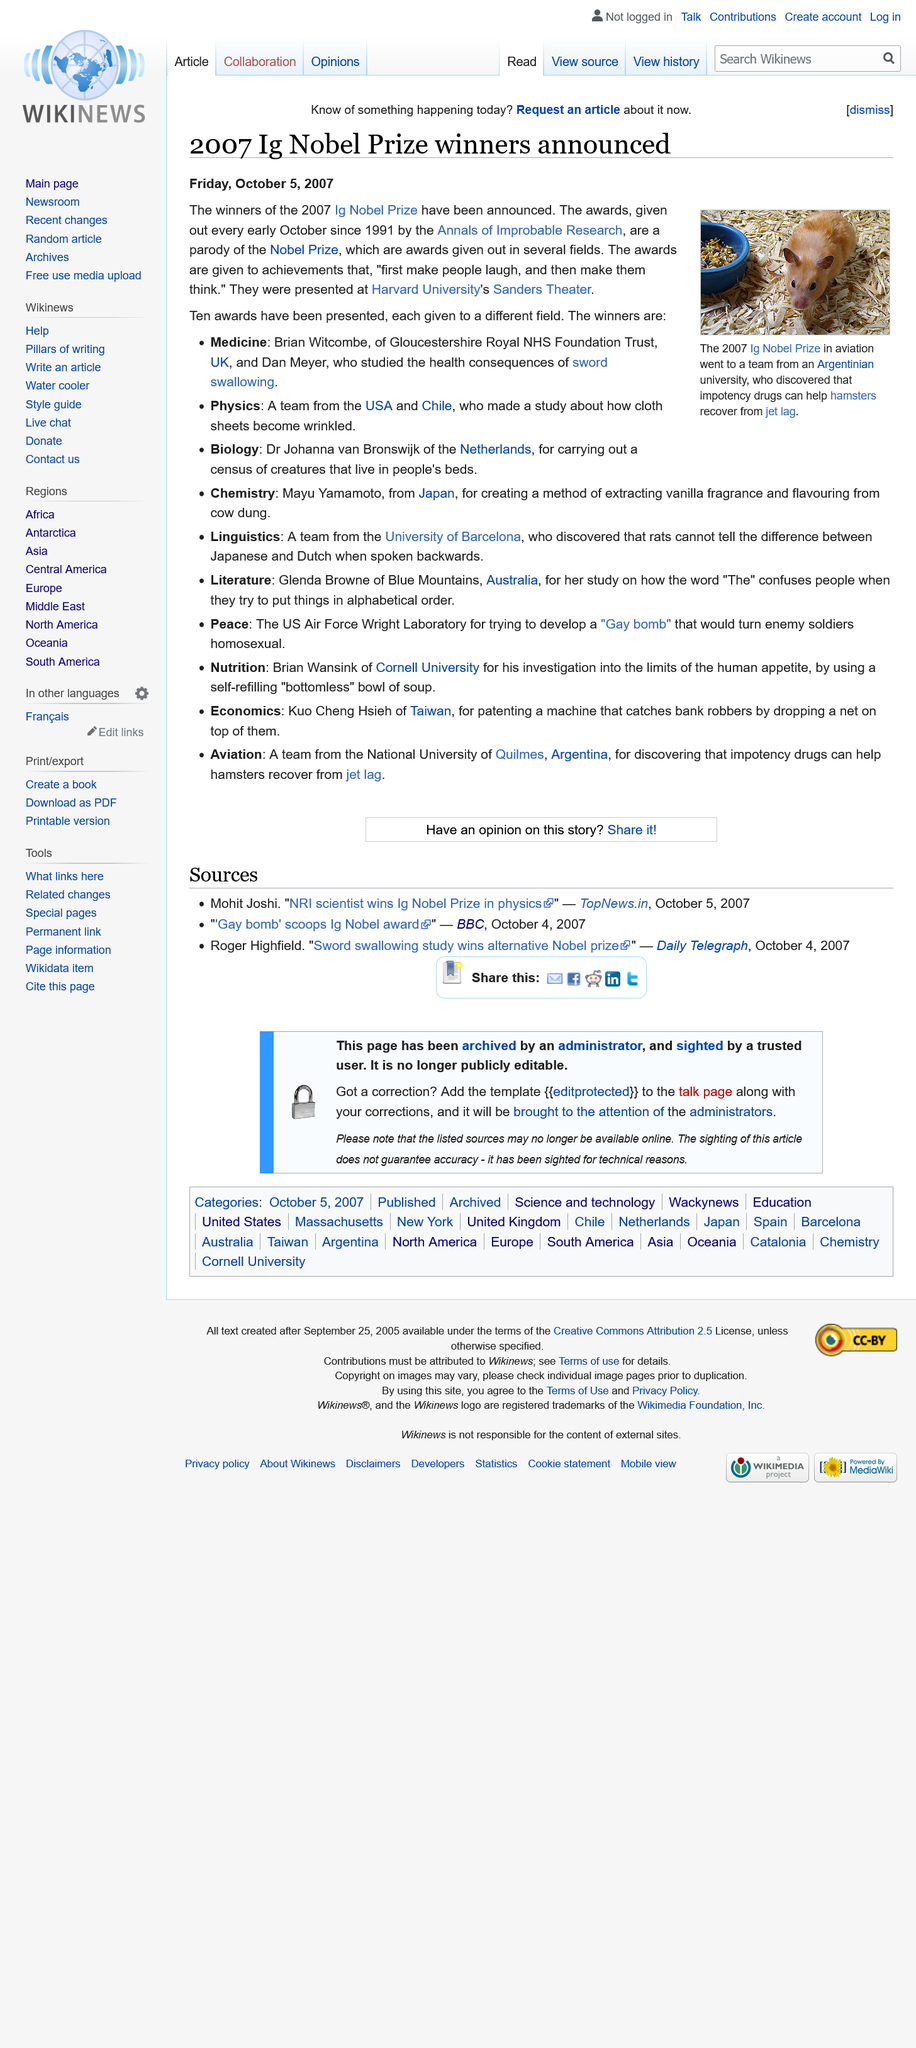Give some essential details in this illustration. Ten Nobel Prize awards were presented. The winners of the Nobel prizes for Biology and Chemistry were Dr Johanna van Bronswijk and Mayu Yamamoto, respectively. The Nobel Prizes are awarded annually in early October. 